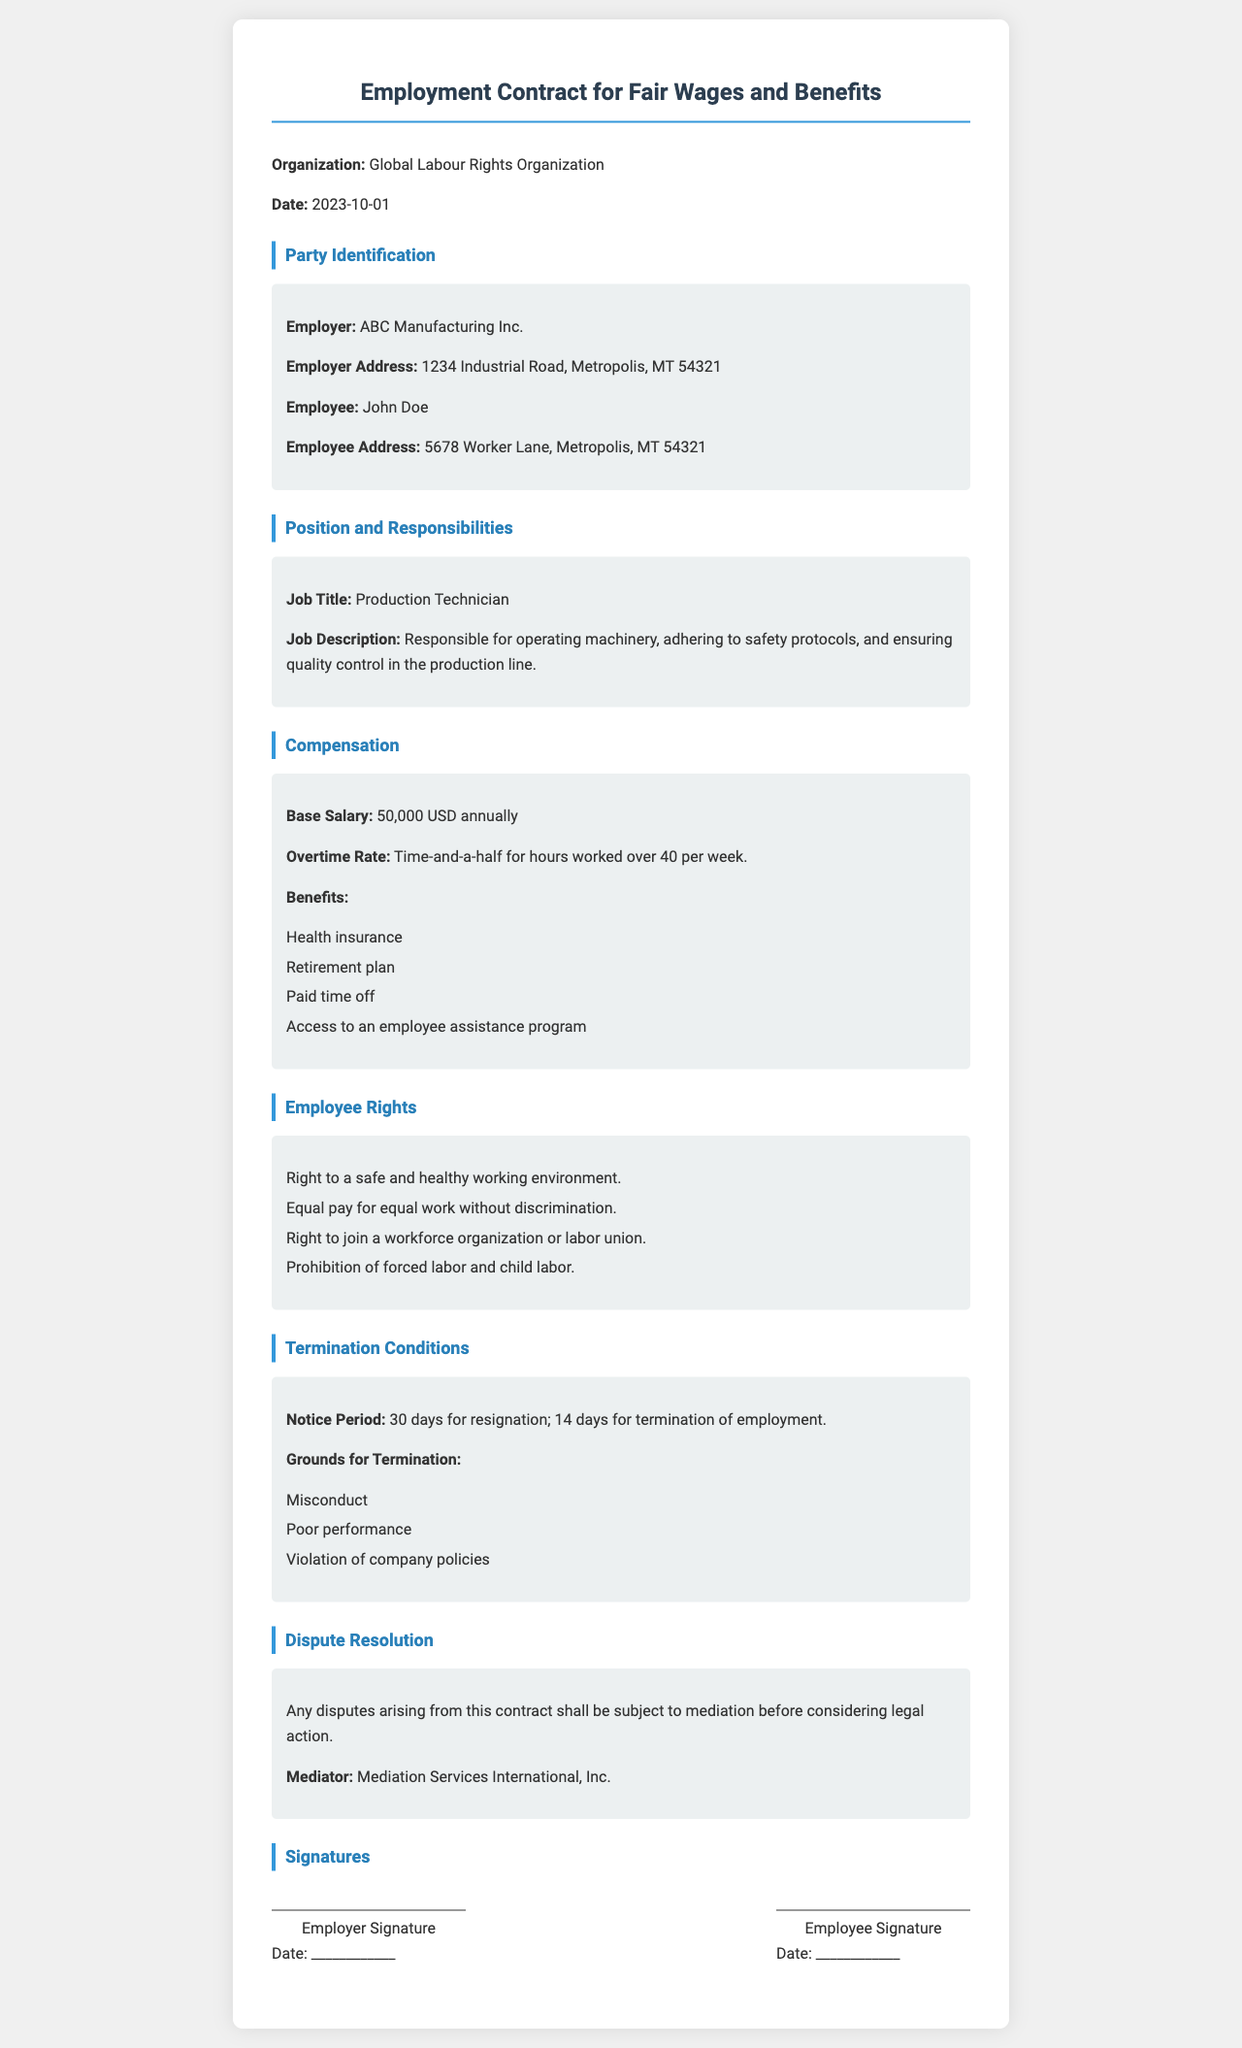what is the name of the employer? The name of the employer is stated in the Party Identification section of the document.
Answer: ABC Manufacturing Inc what is the base salary outlined in the contract? The base salary is mentioned in the Compensation section.
Answer: 50,000 USD annually who is the employee named in the document? The name of the employee is provided in the Party Identification section.
Answer: John Doe how many days notice is required for resignation? The notice period for resignation is detailed in the Termination Conditions section.
Answer: 30 days what benefits are included in the contract? Benefits are listed in the Compensation section and include various types of support for the employee.
Answer: Health insurance, retirement plan, paid time off, access to an employee assistance program what is the mediator's name for dispute resolution? The mediator's name is specified in the Dispute Resolution section of the document.
Answer: Mediation Services International, Inc what is the job title for the employee? The job title is listed in the Position and Responsibilities section.
Answer: Production Technician what grounds can lead to termination according to the contract? Grounds for termination are mentioned in the Termination Conditions section and outline specific reasons.
Answer: Misconduct, poor performance, violation of company policies what is the date of the contract? The contract date is listed at the top of the document.
Answer: 2023-10-01 